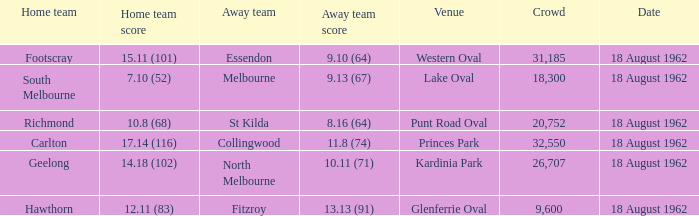At what venue where the home team scored 12.11 (83) was the crowd larger than 31,185? None. 